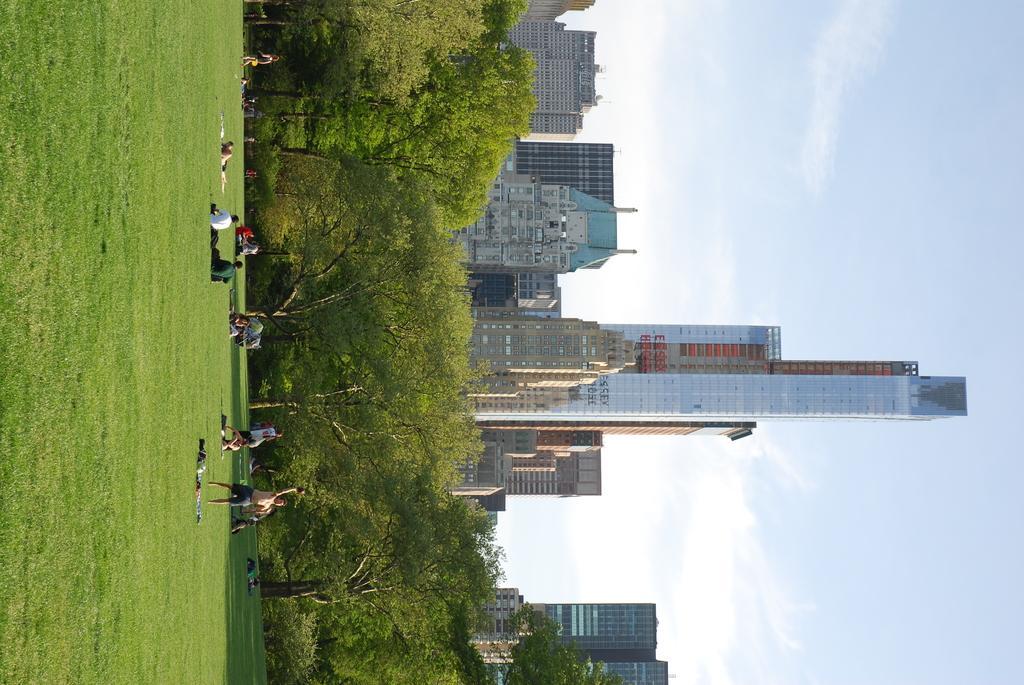How would you summarize this image in a sentence or two? In this image in the center there are persons standing and sitting. In the background there are trees, buildings on the left side there is grass on the ground and the sky is cloudy. 